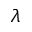<formula> <loc_0><loc_0><loc_500><loc_500>\lambda</formula> 